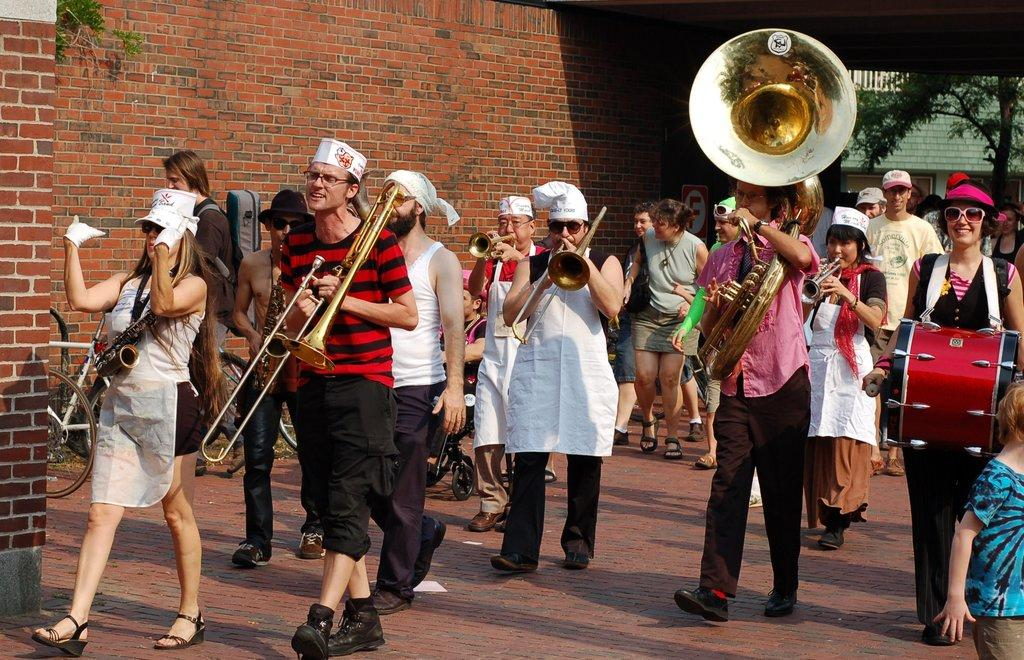What are the people in the image doing? The people in the image are playing music. What are the people holding while playing music? The people are holding musical instruments. What can be seen in the background of the image? There is a brick wall and a tree in the background of the image. What type of scent can be detected from the image? There is no scent present in the image, as it is a visual representation. 